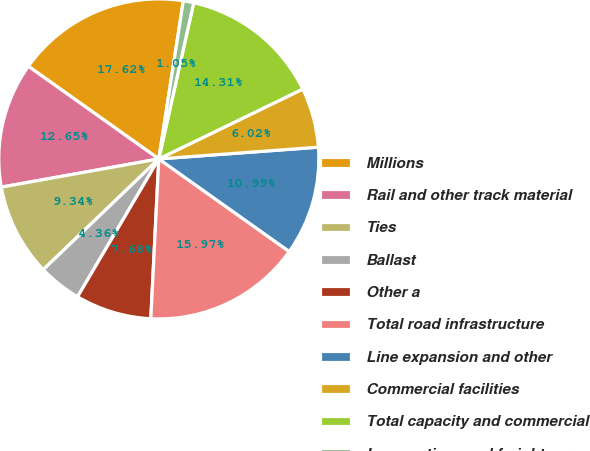Convert chart. <chart><loc_0><loc_0><loc_500><loc_500><pie_chart><fcel>Millions<fcel>Rail and other track material<fcel>Ties<fcel>Ballast<fcel>Other a<fcel>Total road infrastructure<fcel>Line expansion and other<fcel>Commercial facilities<fcel>Total capacity and commercial<fcel>Locomotives and freight cars<nl><fcel>17.62%<fcel>12.65%<fcel>9.34%<fcel>4.36%<fcel>7.68%<fcel>15.97%<fcel>10.99%<fcel>6.02%<fcel>14.31%<fcel>1.05%<nl></chart> 